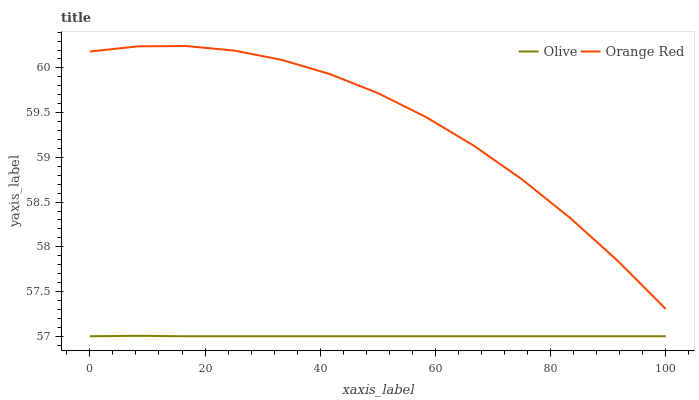Does Olive have the minimum area under the curve?
Answer yes or no. Yes. Does Orange Red have the maximum area under the curve?
Answer yes or no. Yes. Does Orange Red have the minimum area under the curve?
Answer yes or no. No. Is Olive the smoothest?
Answer yes or no. Yes. Is Orange Red the roughest?
Answer yes or no. Yes. Is Orange Red the smoothest?
Answer yes or no. No. Does Olive have the lowest value?
Answer yes or no. Yes. Does Orange Red have the lowest value?
Answer yes or no. No. Does Orange Red have the highest value?
Answer yes or no. Yes. Is Olive less than Orange Red?
Answer yes or no. Yes. Is Orange Red greater than Olive?
Answer yes or no. Yes. Does Olive intersect Orange Red?
Answer yes or no. No. 